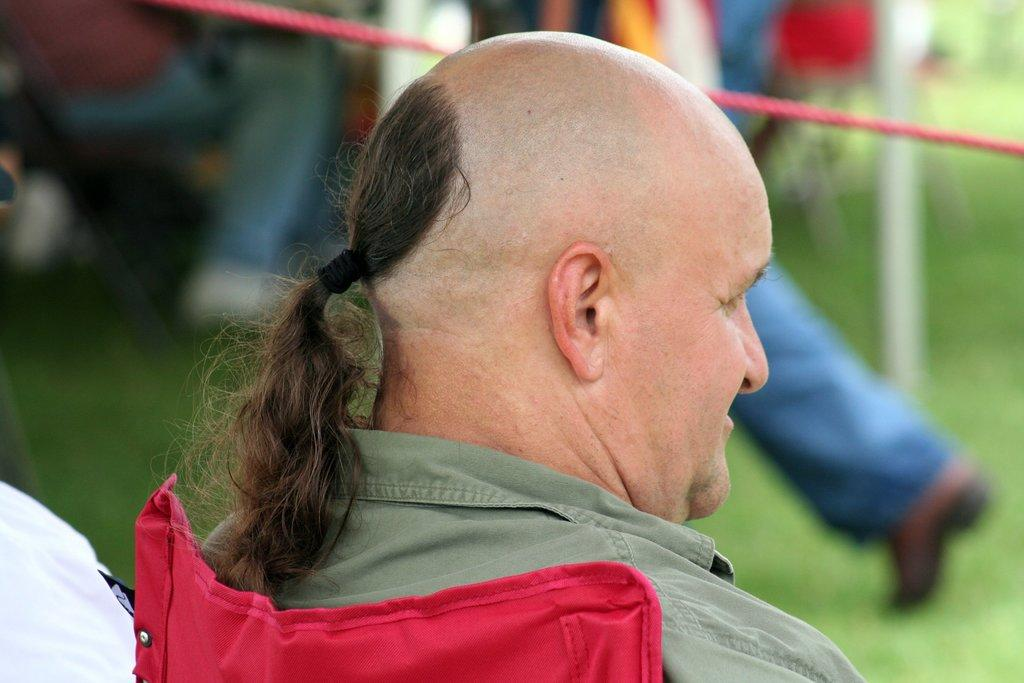What is the position of the person with long hair in the image? The person with long hair is sitting in a chair. Can you describe the background of the image? In the background, there is a person standing on the ground and another person sitting. How many people are present in the image? There are three people in the image. What type of boundary can be seen between the person sitting in the chair and the person standing in the background? There is no boundary visible between the person sitting in the chair and the person standing in the background. What is the weather like in the image? The facts provided do not give any information about the weather, so it cannot be determined from the image. 